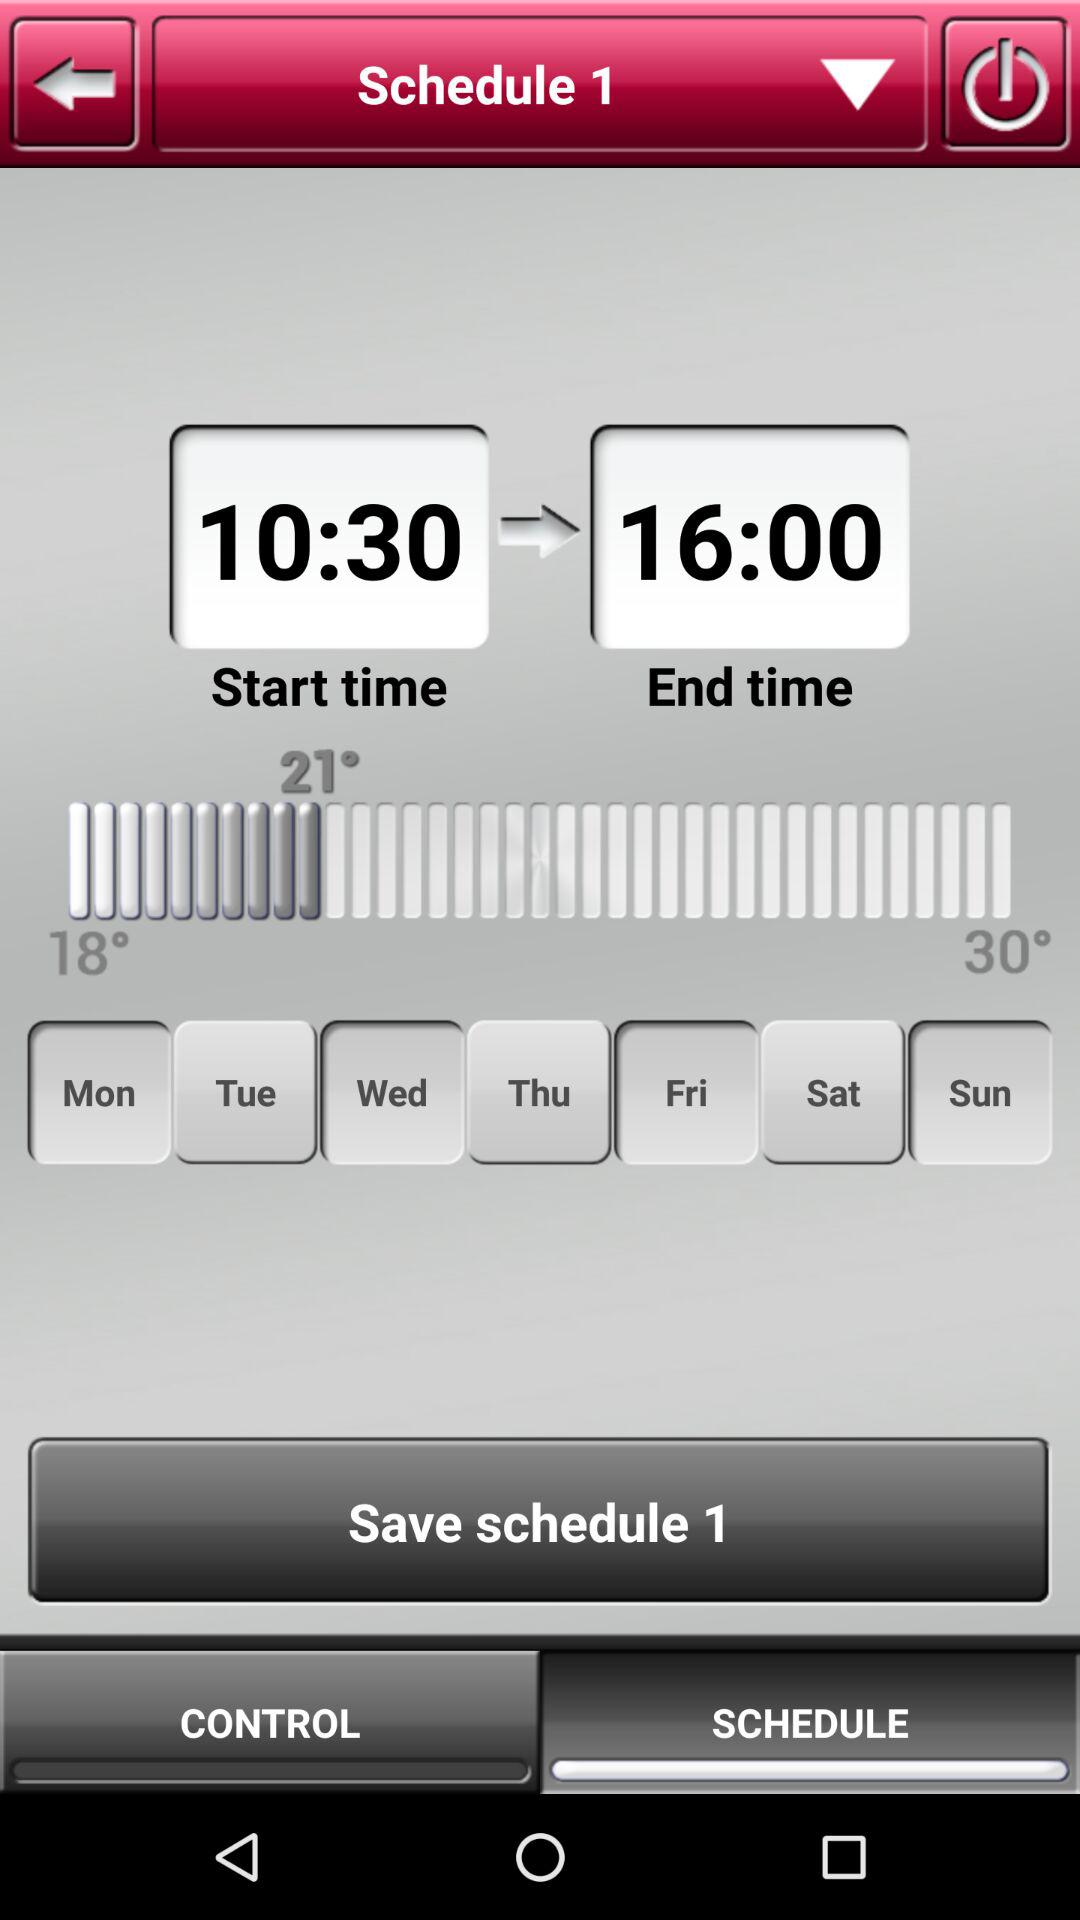How many degrees is the difference between the start and end temperatures?
Answer the question using a single word or phrase. 12 